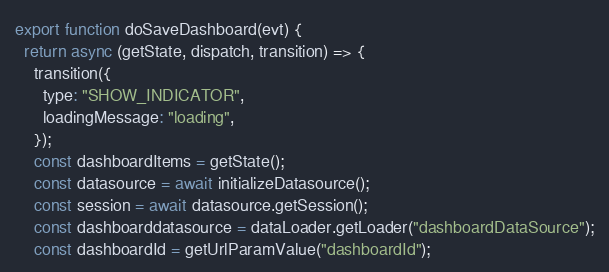<code> <loc_0><loc_0><loc_500><loc_500><_JavaScript_>
export function doSaveDashboard(evt) {
  return async (getState, dispatch, transition) => {
    transition({
      type: "SHOW_INDICATOR",
      loadingMessage: "loading",
    });
    const dashboardItems = getState();
    const datasource = await initializeDatasource();
    const session = await datasource.getSession();
    const dashboarddatasource = dataLoader.getLoader("dashboardDataSource");
    const dashboardId = getUrlParamValue("dashboardId");</code> 